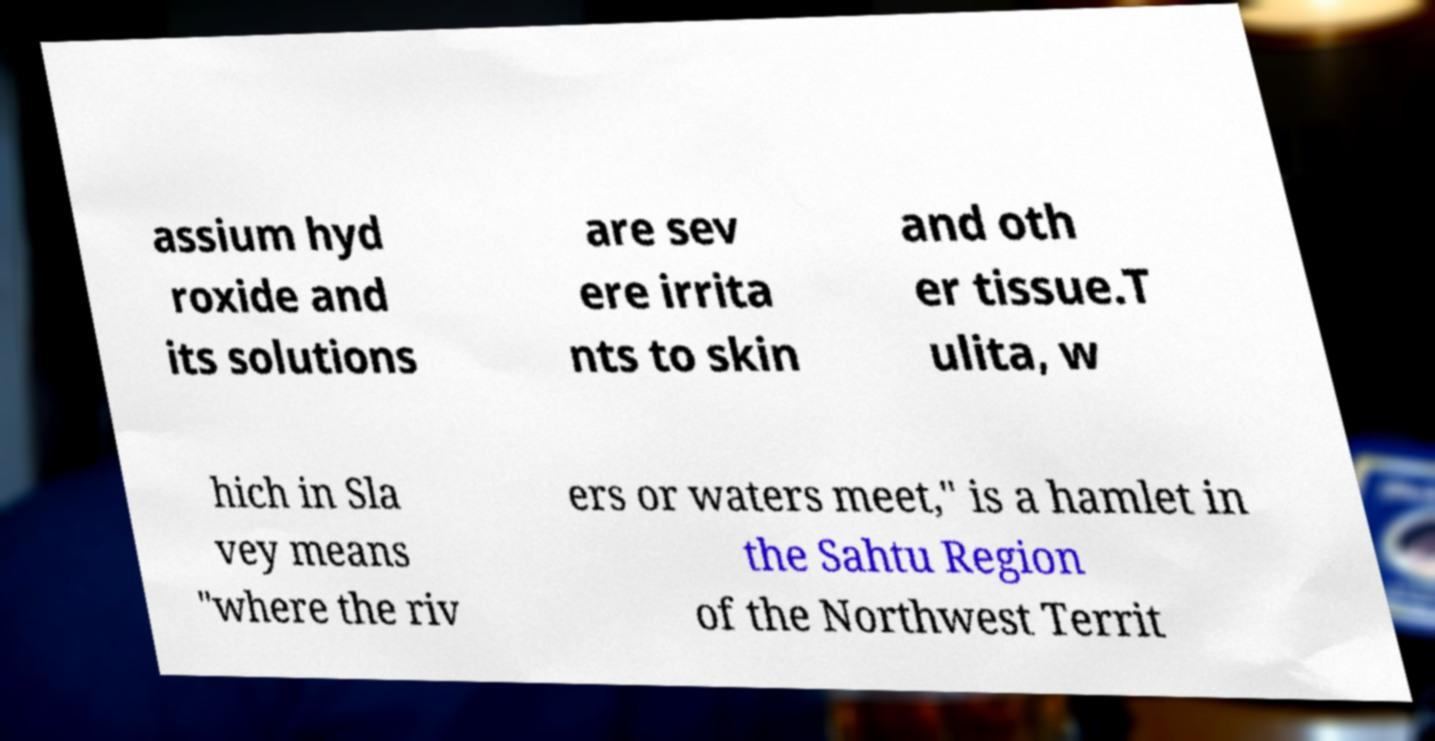Can you accurately transcribe the text from the provided image for me? assium hyd roxide and its solutions are sev ere irrita nts to skin and oth er tissue.T ulita, w hich in Sla vey means "where the riv ers or waters meet," is a hamlet in the Sahtu Region of the Northwest Territ 